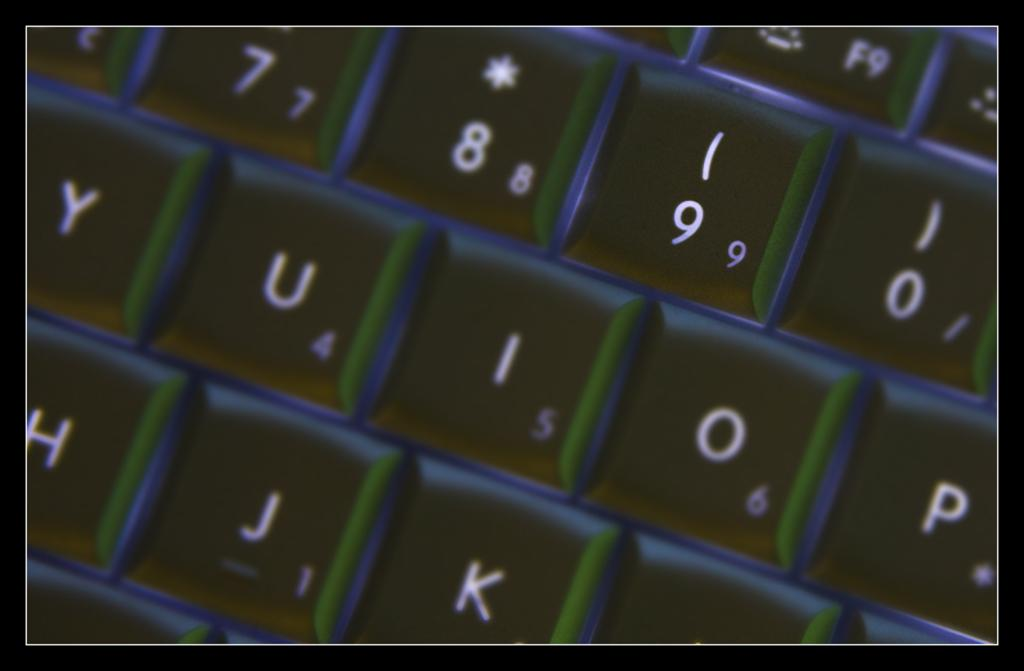<image>
Offer a succinct explanation of the picture presented. A keyboard with black keys and the numbers 7,8,9, and 0 showing. 